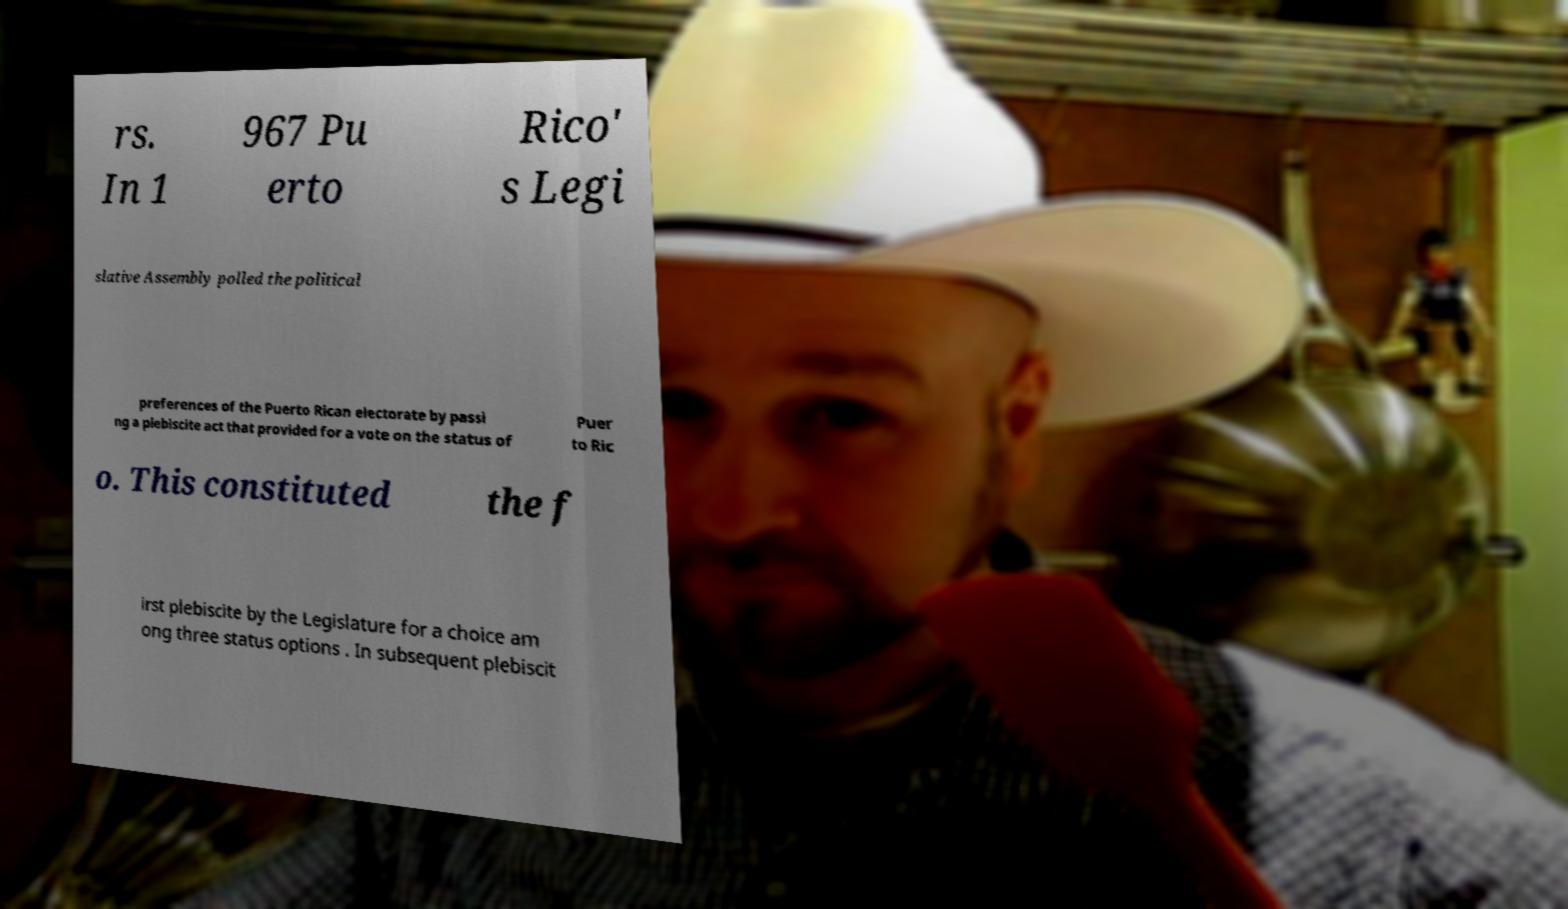Can you accurately transcribe the text from the provided image for me? rs. In 1 967 Pu erto Rico' s Legi slative Assembly polled the political preferences of the Puerto Rican electorate by passi ng a plebiscite act that provided for a vote on the status of Puer to Ric o. This constituted the f irst plebiscite by the Legislature for a choice am ong three status options . In subsequent plebiscit 